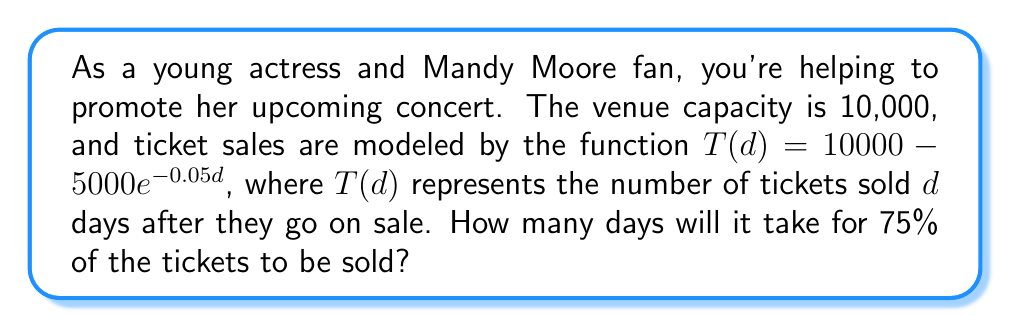Provide a solution to this math problem. Let's approach this step-by-step:

1) We need to find $d$ when $T(d) = 7500$ (75% of 10,000).

2) Let's set up the equation:
   $7500 = 10000 - 5000e^{-0.05d}$

3) Subtract 10000 from both sides:
   $-2500 = -5000e^{-0.05d}$

4) Divide both sides by -5000:
   $0.5 = e^{-0.05d}$

5) Take the natural log of both sides:
   $\ln(0.5) = -0.05d$

6) Solve for $d$:
   $d = \frac{\ln(0.5)}{-0.05}$

7) Calculate:
   $d = \frac{-0.693147...}{-0.05} \approx 13.86$ days

8) Since we can't have a fractional day, we round up to the next whole day.
Answer: It will take 14 days for 75% of the tickets to be sold. 